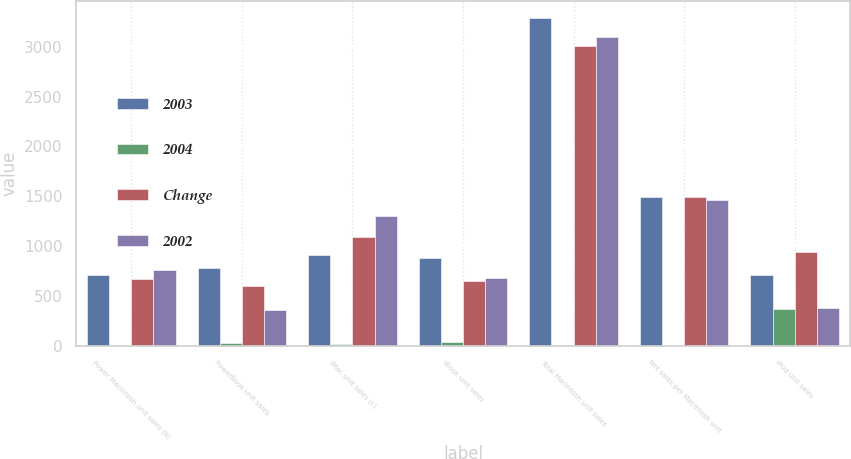Convert chart to OTSL. <chart><loc_0><loc_0><loc_500><loc_500><stacked_bar_chart><ecel><fcel>Power Macintosh unit sales (b)<fcel>PowerBook unit sales<fcel>iMac unit sales (c)<fcel>iBook unit sales<fcel>Total Macintosh unit sales<fcel>Net sales per Macintosh unit<fcel>iPod unit sales<nl><fcel>2003<fcel>709<fcel>785<fcel>916<fcel>880<fcel>3290<fcel>1496<fcel>709<nl><fcel>2004<fcel>6<fcel>30<fcel>16<fcel>36<fcel>9<fcel>0<fcel>370<nl><fcel>Change<fcel>667<fcel>604<fcel>1094<fcel>647<fcel>3012<fcel>1491<fcel>939<nl><fcel>2002<fcel>766<fcel>357<fcel>1301<fcel>677<fcel>3101<fcel>1462<fcel>381<nl></chart> 